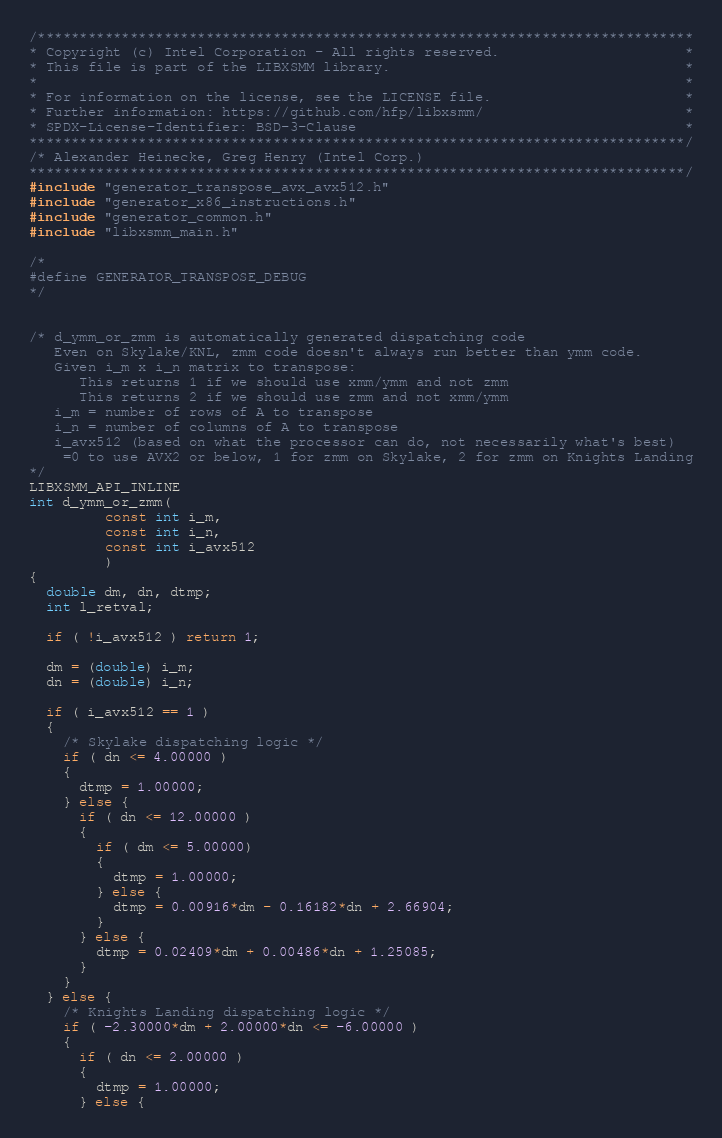<code> <loc_0><loc_0><loc_500><loc_500><_C_>/******************************************************************************
* Copyright (c) Intel Corporation - All rights reserved.                      *
* This file is part of the LIBXSMM library.                                   *
*                                                                             *
* For information on the license, see the LICENSE file.                       *
* Further information: https://github.com/hfp/libxsmm/                        *
* SPDX-License-Identifier: BSD-3-Clause                                       *
******************************************************************************/
/* Alexander Heinecke, Greg Henry (Intel Corp.)
******************************************************************************/
#include "generator_transpose_avx_avx512.h"
#include "generator_x86_instructions.h"
#include "generator_common.h"
#include "libxsmm_main.h"

/*
#define GENERATOR_TRANSPOSE_DEBUG
*/


/* d_ymm_or_zmm is automatically generated dispatching code
   Even on Skylake/KNL, zmm code doesn't always run better than ymm code.
   Given i_m x i_n matrix to transpose:
      This returns 1 if we should use xmm/ymm and not zmm
      This returns 2 if we should use zmm and not xmm/ymm
   i_m = number of rows of A to transpose
   i_n = number of columns of A to transpose
   i_avx512 (based on what the processor can do, not necessarily what's best)
    =0 to use AVX2 or below, 1 for zmm on Skylake, 2 for zmm on Knights Landing
*/
LIBXSMM_API_INLINE
int d_ymm_or_zmm(
         const int i_m,
         const int i_n,
         const int i_avx512
         )
{
  double dm, dn, dtmp;
  int l_retval;

  if ( !i_avx512 ) return 1;

  dm = (double) i_m;
  dn = (double) i_n;

  if ( i_avx512 == 1 )
  {
    /* Skylake dispatching logic */
    if ( dn <= 4.00000 )
    {
      dtmp = 1.00000;
    } else {
      if ( dn <= 12.00000 )
      {
        if ( dm <= 5.00000)
        {
          dtmp = 1.00000;
        } else {
          dtmp = 0.00916*dm - 0.16182*dn + 2.66904;
        }
      } else {
        dtmp = 0.02409*dm + 0.00486*dn + 1.25085;
      }
    }
  } else {
    /* Knights Landing dispatching logic */
    if ( -2.30000*dm + 2.00000*dn <= -6.00000 )
    {
      if ( dn <= 2.00000 )
      {
        dtmp = 1.00000;
      } else {</code> 